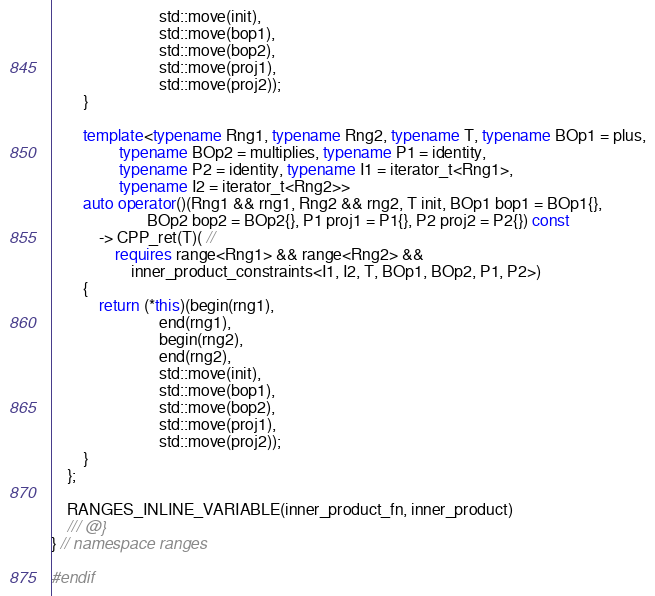Convert code to text. <code><loc_0><loc_0><loc_500><loc_500><_C++_>                           std::move(init),
                           std::move(bop1),
                           std::move(bop2),
                           std::move(proj1),
                           std::move(proj2));
        }

        template<typename Rng1, typename Rng2, typename T, typename BOp1 = plus,
                 typename BOp2 = multiplies, typename P1 = identity,
                 typename P2 = identity, typename I1 = iterator_t<Rng1>,
                 typename I2 = iterator_t<Rng2>>
        auto operator()(Rng1 && rng1, Rng2 && rng2, T init, BOp1 bop1 = BOp1{},
                        BOp2 bop2 = BOp2{}, P1 proj1 = P1{}, P2 proj2 = P2{}) const
            -> CPP_ret(T)( //
                requires range<Rng1> && range<Rng2> &&
                    inner_product_constraints<I1, I2, T, BOp1, BOp2, P1, P2>)
        {
            return (*this)(begin(rng1),
                           end(rng1),
                           begin(rng2),
                           end(rng2),
                           std::move(init),
                           std::move(bop1),
                           std::move(bop2),
                           std::move(proj1),
                           std::move(proj2));
        }
    };

    RANGES_INLINE_VARIABLE(inner_product_fn, inner_product)
    /// @}
} // namespace ranges

#endif
</code> 